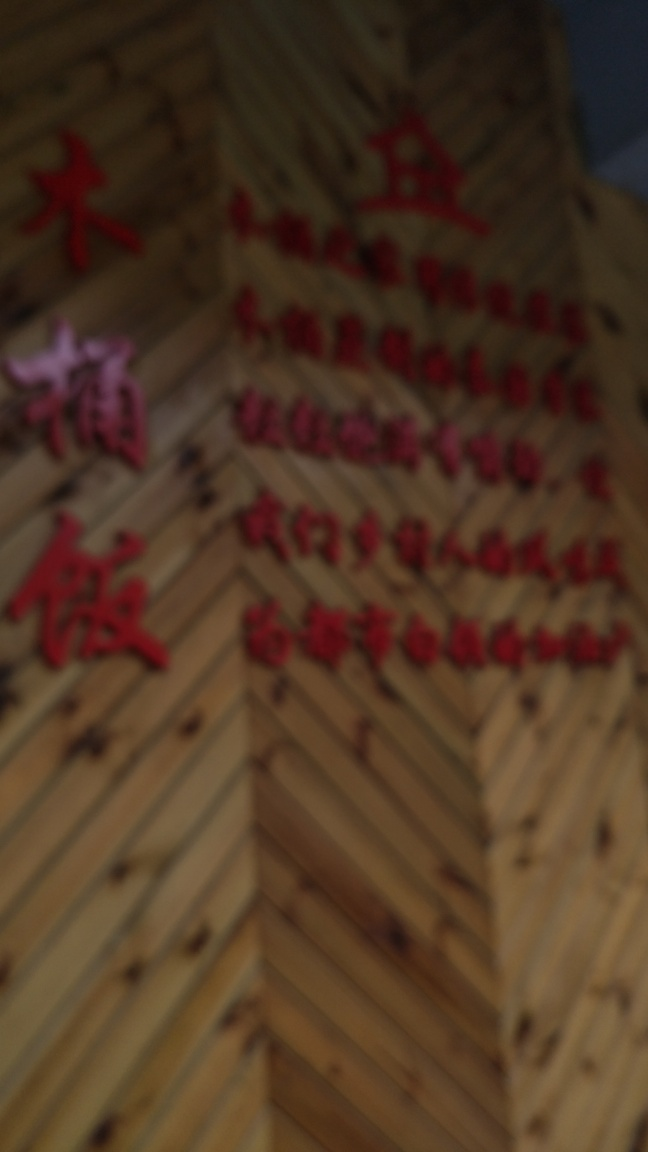Can you guess what is written in the image despite the blur? It's challenging to decipher the text accurately due to the blurriness. The characters appear to be of an East Asian language, possibly Chinese, based on their structure and form. Without clearer resolution, providing a precise transcription or translation is not feasible. 